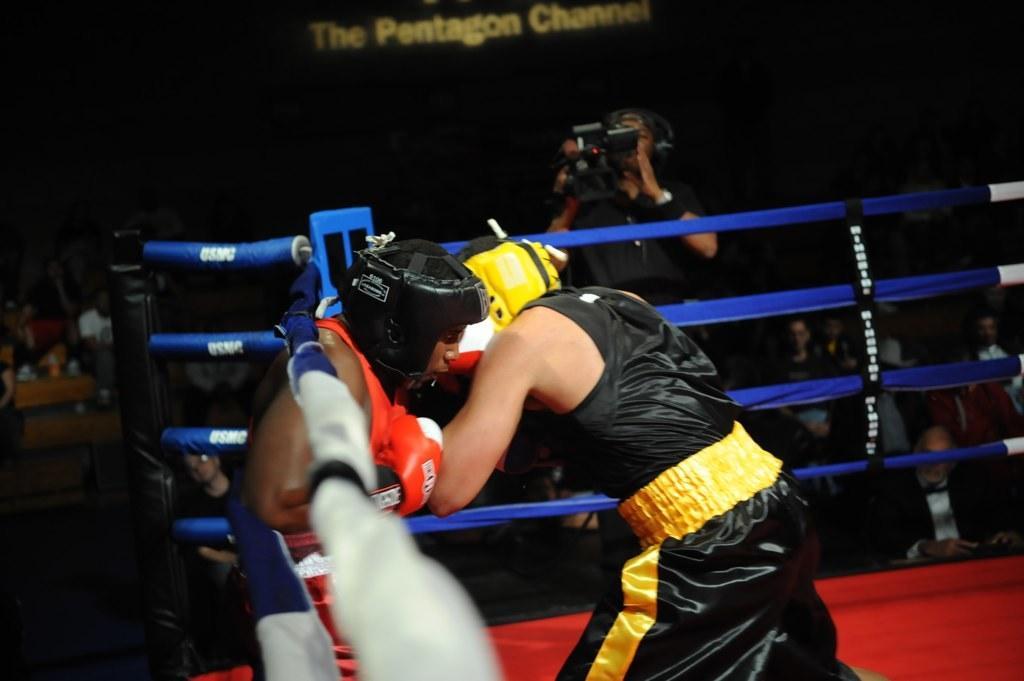Please provide a concise description of this image. In this image in the foreground there are two persons who are fighting, and they are in boxing ring. And in the background there is one person holding camera, and also there are group of people. At the top of the image there is some text visible and at the bottom there might be a carpet. 